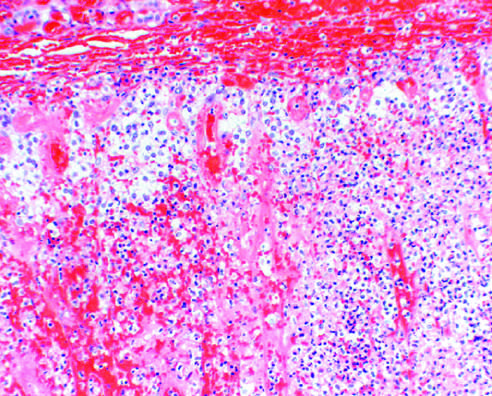what result in acute adrenal insufficiency?
Answer the question using a single word or phrase. Bilateral adrenal hemorrhage 